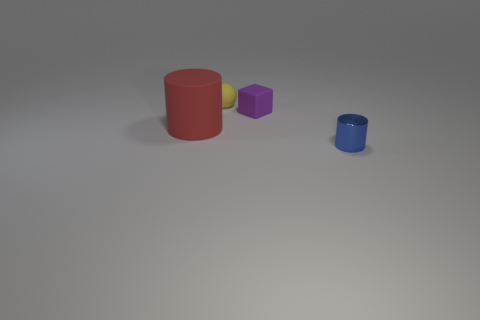Add 1 cylinders. How many objects exist? 5 Subtract all balls. How many objects are left? 3 Subtract all yellow rubber blocks. Subtract all small blue shiny cylinders. How many objects are left? 3 Add 4 small purple blocks. How many small purple blocks are left? 5 Add 2 large blue matte spheres. How many large blue matte spheres exist? 2 Subtract 0 yellow cylinders. How many objects are left? 4 